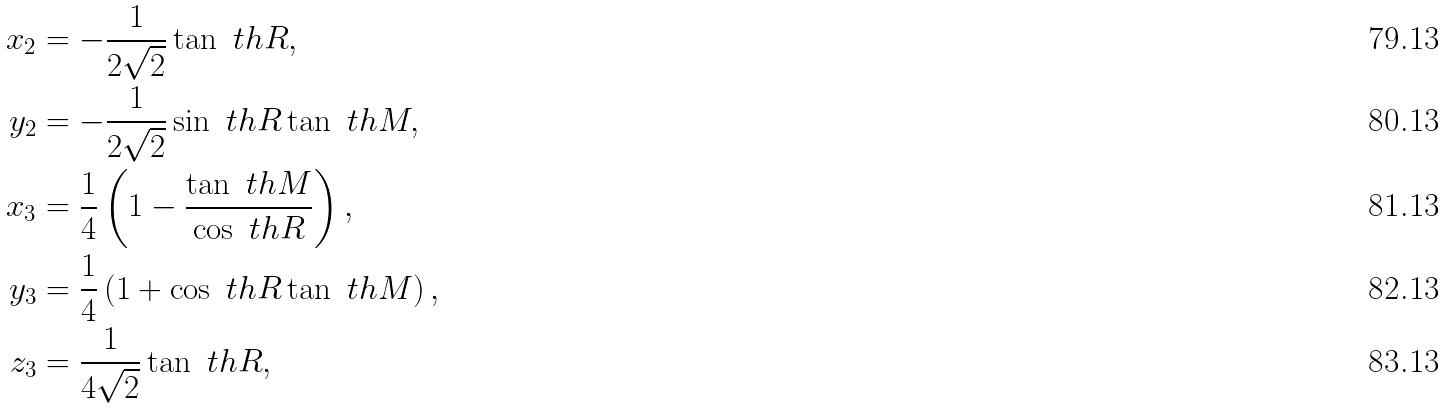Convert formula to latex. <formula><loc_0><loc_0><loc_500><loc_500>x _ { 2 } & = - \frac { 1 } { 2 \sqrt { 2 } } \tan \ t h R , \\ y _ { 2 } & = - \frac { 1 } { 2 \sqrt { 2 } } \sin \ t h R \tan \ t h M , \\ x _ { 3 } & = \frac { 1 } { 4 } \left ( 1 - \frac { \tan \ t h M } { \cos \ t h R } \right ) , \\ y _ { 3 } & = \frac { 1 } { 4 } \left ( 1 + \cos \ t h R \tan \ t h M \right ) , \\ z _ { 3 } & = \frac { 1 } { 4 \sqrt { 2 } } \tan \ t h R ,</formula> 